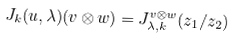<formula> <loc_0><loc_0><loc_500><loc_500>J _ { k } ( u , \lambda ) ( v \otimes w ) = J _ { \lambda , k } ^ { v \otimes w } ( z _ { 1 } / z _ { 2 } )</formula> 